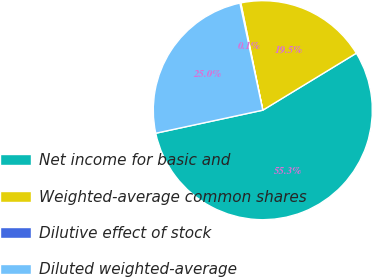<chart> <loc_0><loc_0><loc_500><loc_500><pie_chart><fcel>Net income for basic and<fcel>Weighted-average common shares<fcel>Dilutive effect of stock<fcel>Diluted weighted-average<nl><fcel>55.33%<fcel>19.51%<fcel>0.13%<fcel>25.03%<nl></chart> 